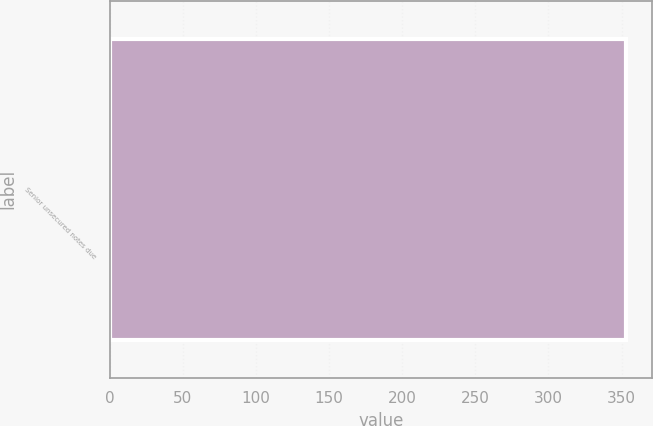Convert chart. <chart><loc_0><loc_0><loc_500><loc_500><bar_chart><fcel>Senior unsecured notes due<nl><fcel>353<nl></chart> 